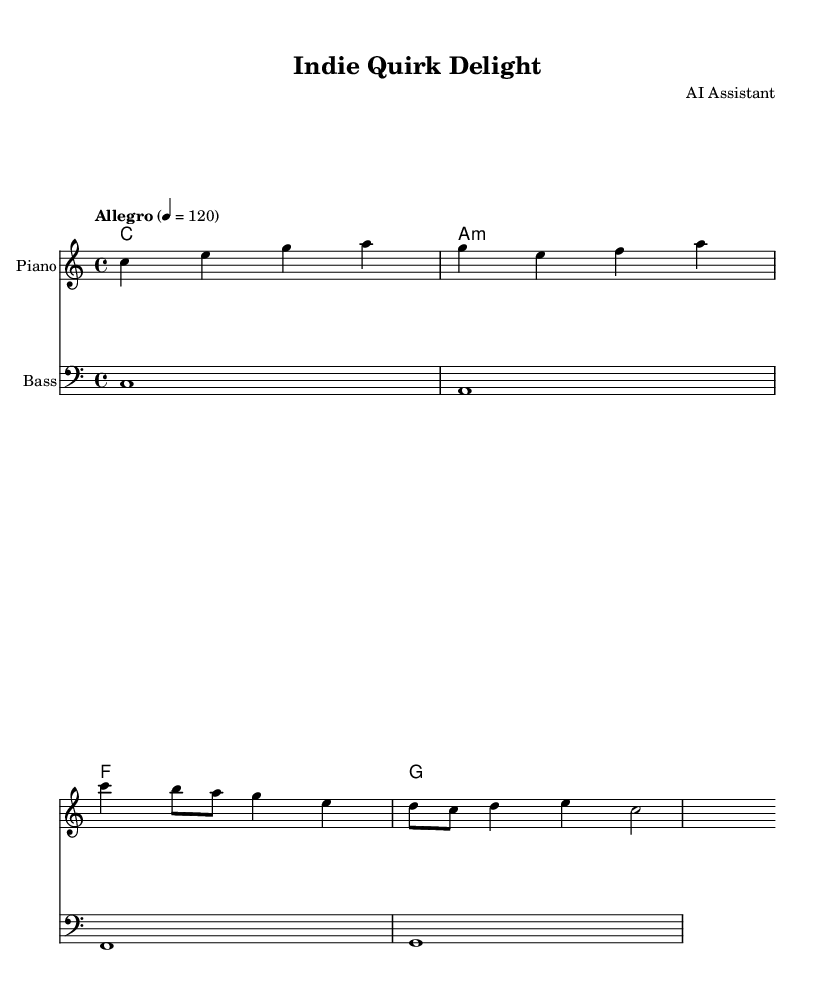What is the key signature of this music? The key signature is C major, which has no sharps or flats indicated in the score.
Answer: C major What is the time signature of this music? The time signature is shown at the beginning of the score as 4/4, meaning there are four beats in a measure and a quarter note gets one beat.
Answer: 4/4 What is the tempo marking for this piece? The tempo marking indicates "Allegro" with a metronome marking of 120 beats per minute, suggesting a lively and brisk pace.
Answer: Allegro, 120 How many measures are in the melody? Counting the melody section, there are four measures visible in total, each separated by vertical lines.
Answer: 4 measures What type of texture does this music exhibit? Based on the score, it features a homophonic texture with a clear melody accompanied by chords, evident from the harmonic structure beneath the melody line.
Answer: Homophonic What is the style or mood suggested by the tempo and key signature? Given the cheerful C major key and upbeat "Allegro" tempo, the music suggests a quirky and uplifting mood, characteristic of indie comedy soundtracks.
Answer: Quirky and uplifting What instruments are indicated for this piece? The score specifies a piano for the melody and an acoustic bass for the bass line, which reflects a typical arrangement in indie soundtracks.
Answer: Piano and acoustic bass 